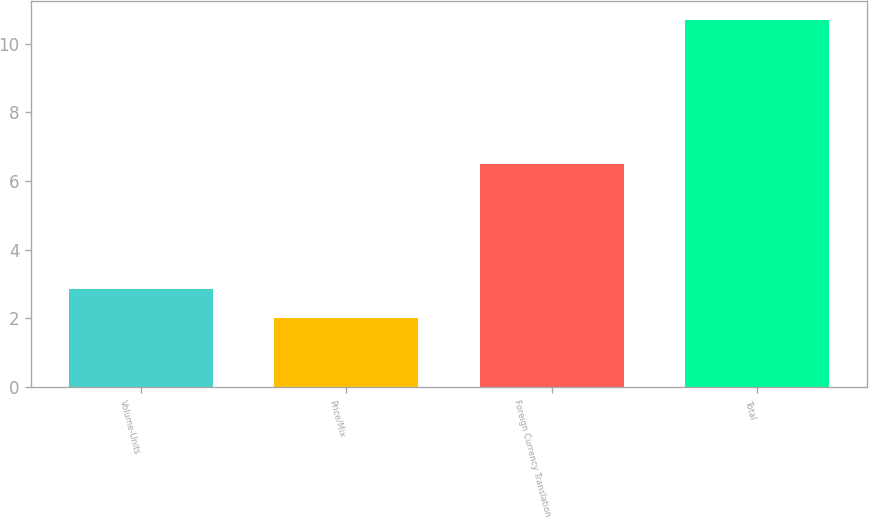<chart> <loc_0><loc_0><loc_500><loc_500><bar_chart><fcel>Volume-Units<fcel>Price/Mix<fcel>Foreign Currency Translation<fcel>Total<nl><fcel>2.87<fcel>2<fcel>6.5<fcel>10.7<nl></chart> 